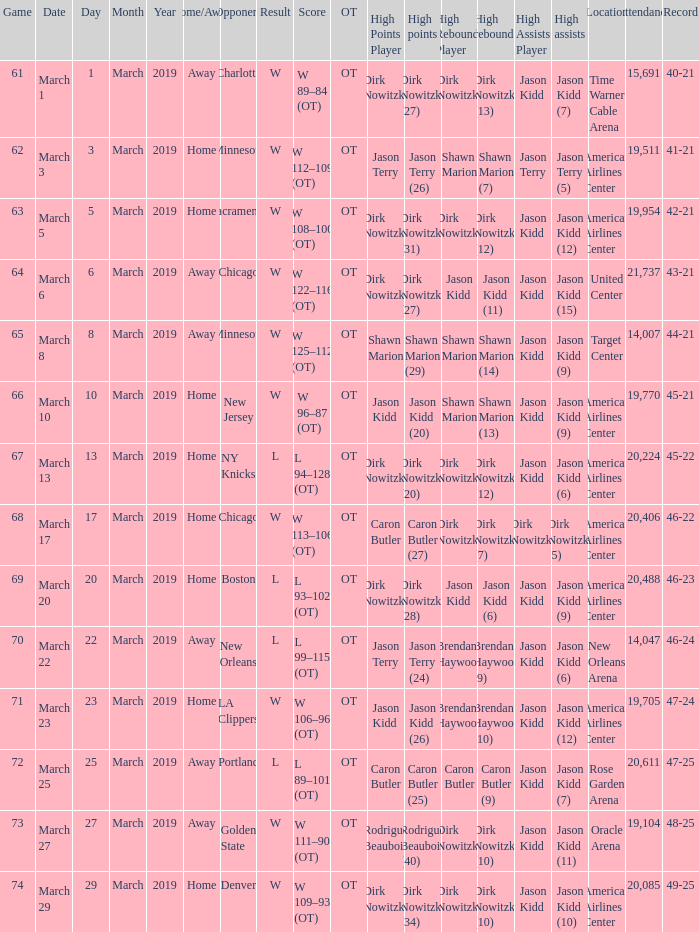List the stadium and number of people in attendance when the team record was 45-22. 1.0. 